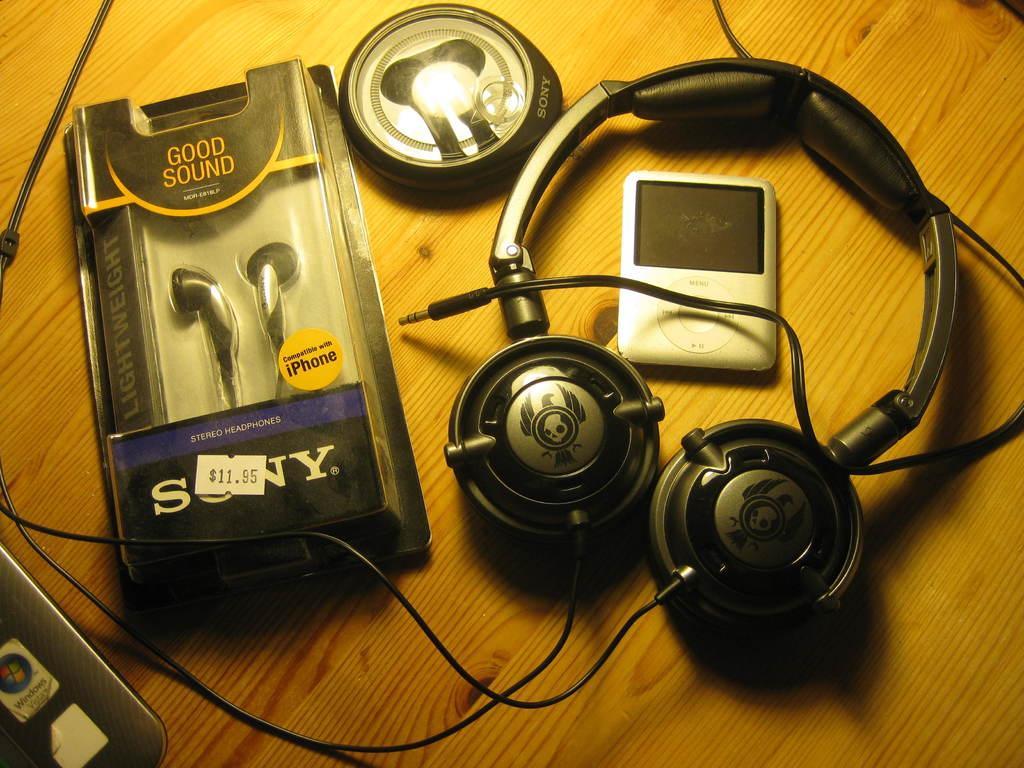In one or two sentences, can you explain what this image depicts? In the image on the wooden surface there are headphones with wire. And there are headsets inside the packet. There is a round shape box with headsets. And also there is an iPod. In the bottom left corner of the image there is a part of an object with stickers. 